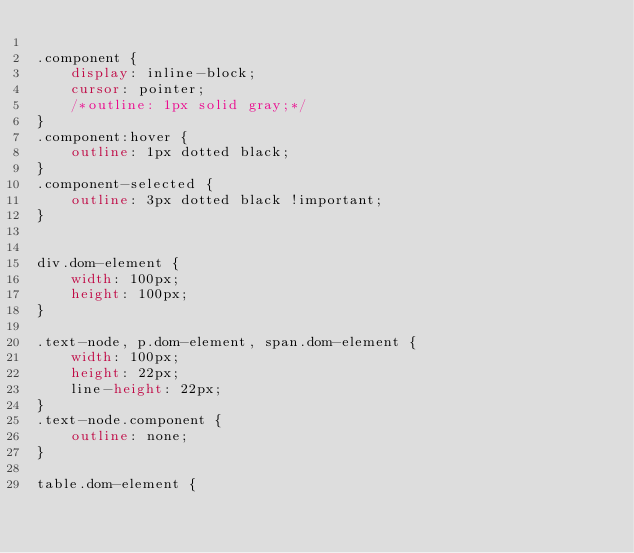Convert code to text. <code><loc_0><loc_0><loc_500><loc_500><_CSS_>
.component {
    display: inline-block;
    cursor: pointer;
    /*outline: 1px solid gray;*/
}
.component:hover {
    outline: 1px dotted black;
}
.component-selected {
    outline: 3px dotted black !important;
}


div.dom-element {
    width: 100px;
    height: 100px;
}

.text-node, p.dom-element, span.dom-element {
    width: 100px;
    height: 22px;
    line-height: 22px;
}
.text-node.component {
    outline: none;
}

table.dom-element {</code> 